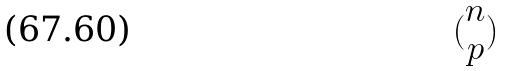Convert formula to latex. <formula><loc_0><loc_0><loc_500><loc_500>( \begin{matrix} n \\ p \end{matrix} )</formula> 